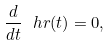<formula> <loc_0><loc_0><loc_500><loc_500>\frac { d } { d t } \ h r ( t ) = 0 ,</formula> 